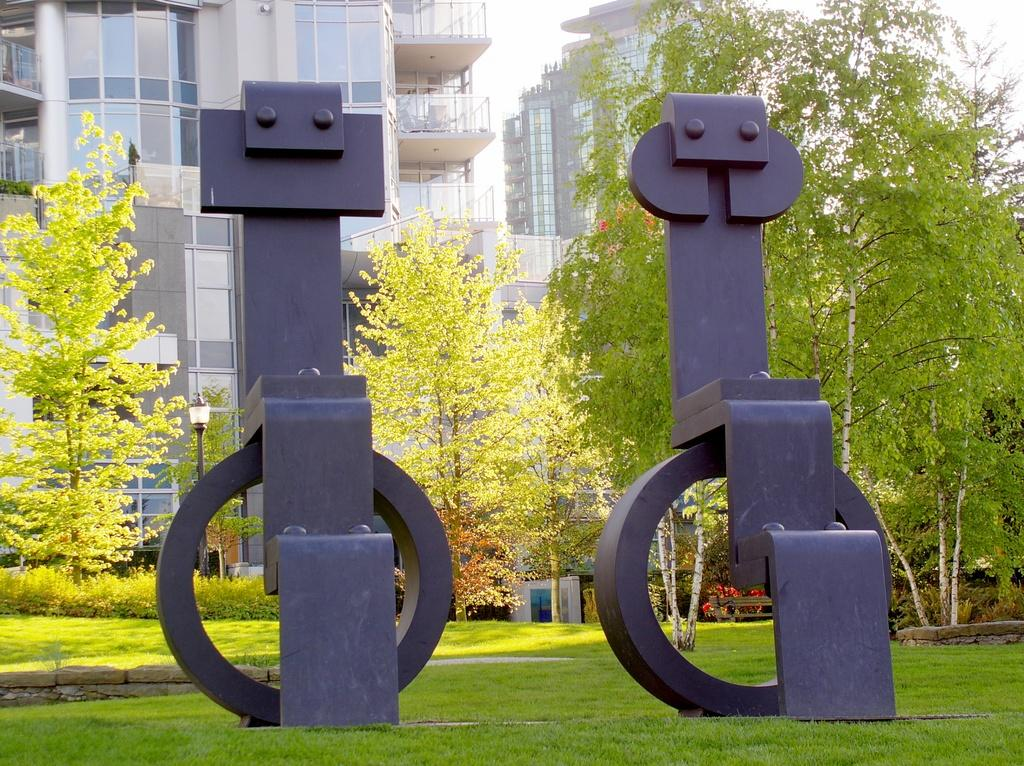What structures can be seen in the image? There are poles in the image. What can be seen in the distance in the image? There are trees and buildings in the background of the image. What type of seating is present in the image? There is a bench in the image. What type of copper material can be seen on the poles in the image? There is no mention of copper or any specific material for the poles in the image. 